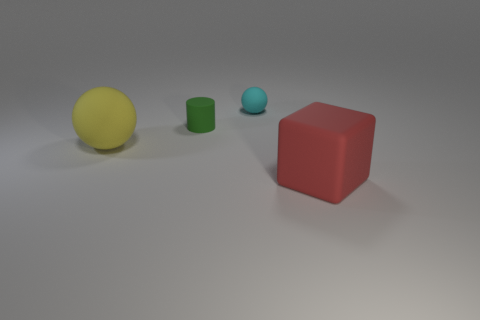Add 3 big rubber things. How many objects exist? 7 Subtract all blocks. How many objects are left? 3 Add 1 big rubber things. How many big rubber things are left? 3 Add 1 large green blocks. How many large green blocks exist? 1 Subtract 0 blue blocks. How many objects are left? 4 Subtract all large red objects. Subtract all matte spheres. How many objects are left? 1 